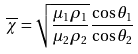<formula> <loc_0><loc_0><loc_500><loc_500>\overline { \chi } = \sqrt { \frac { \mu _ { 1 } \rho _ { 1 } } { \mu _ { 2 } \rho _ { 2 } } } \frac { \cos \theta _ { 1 } } { \cos \theta _ { 2 } }</formula> 